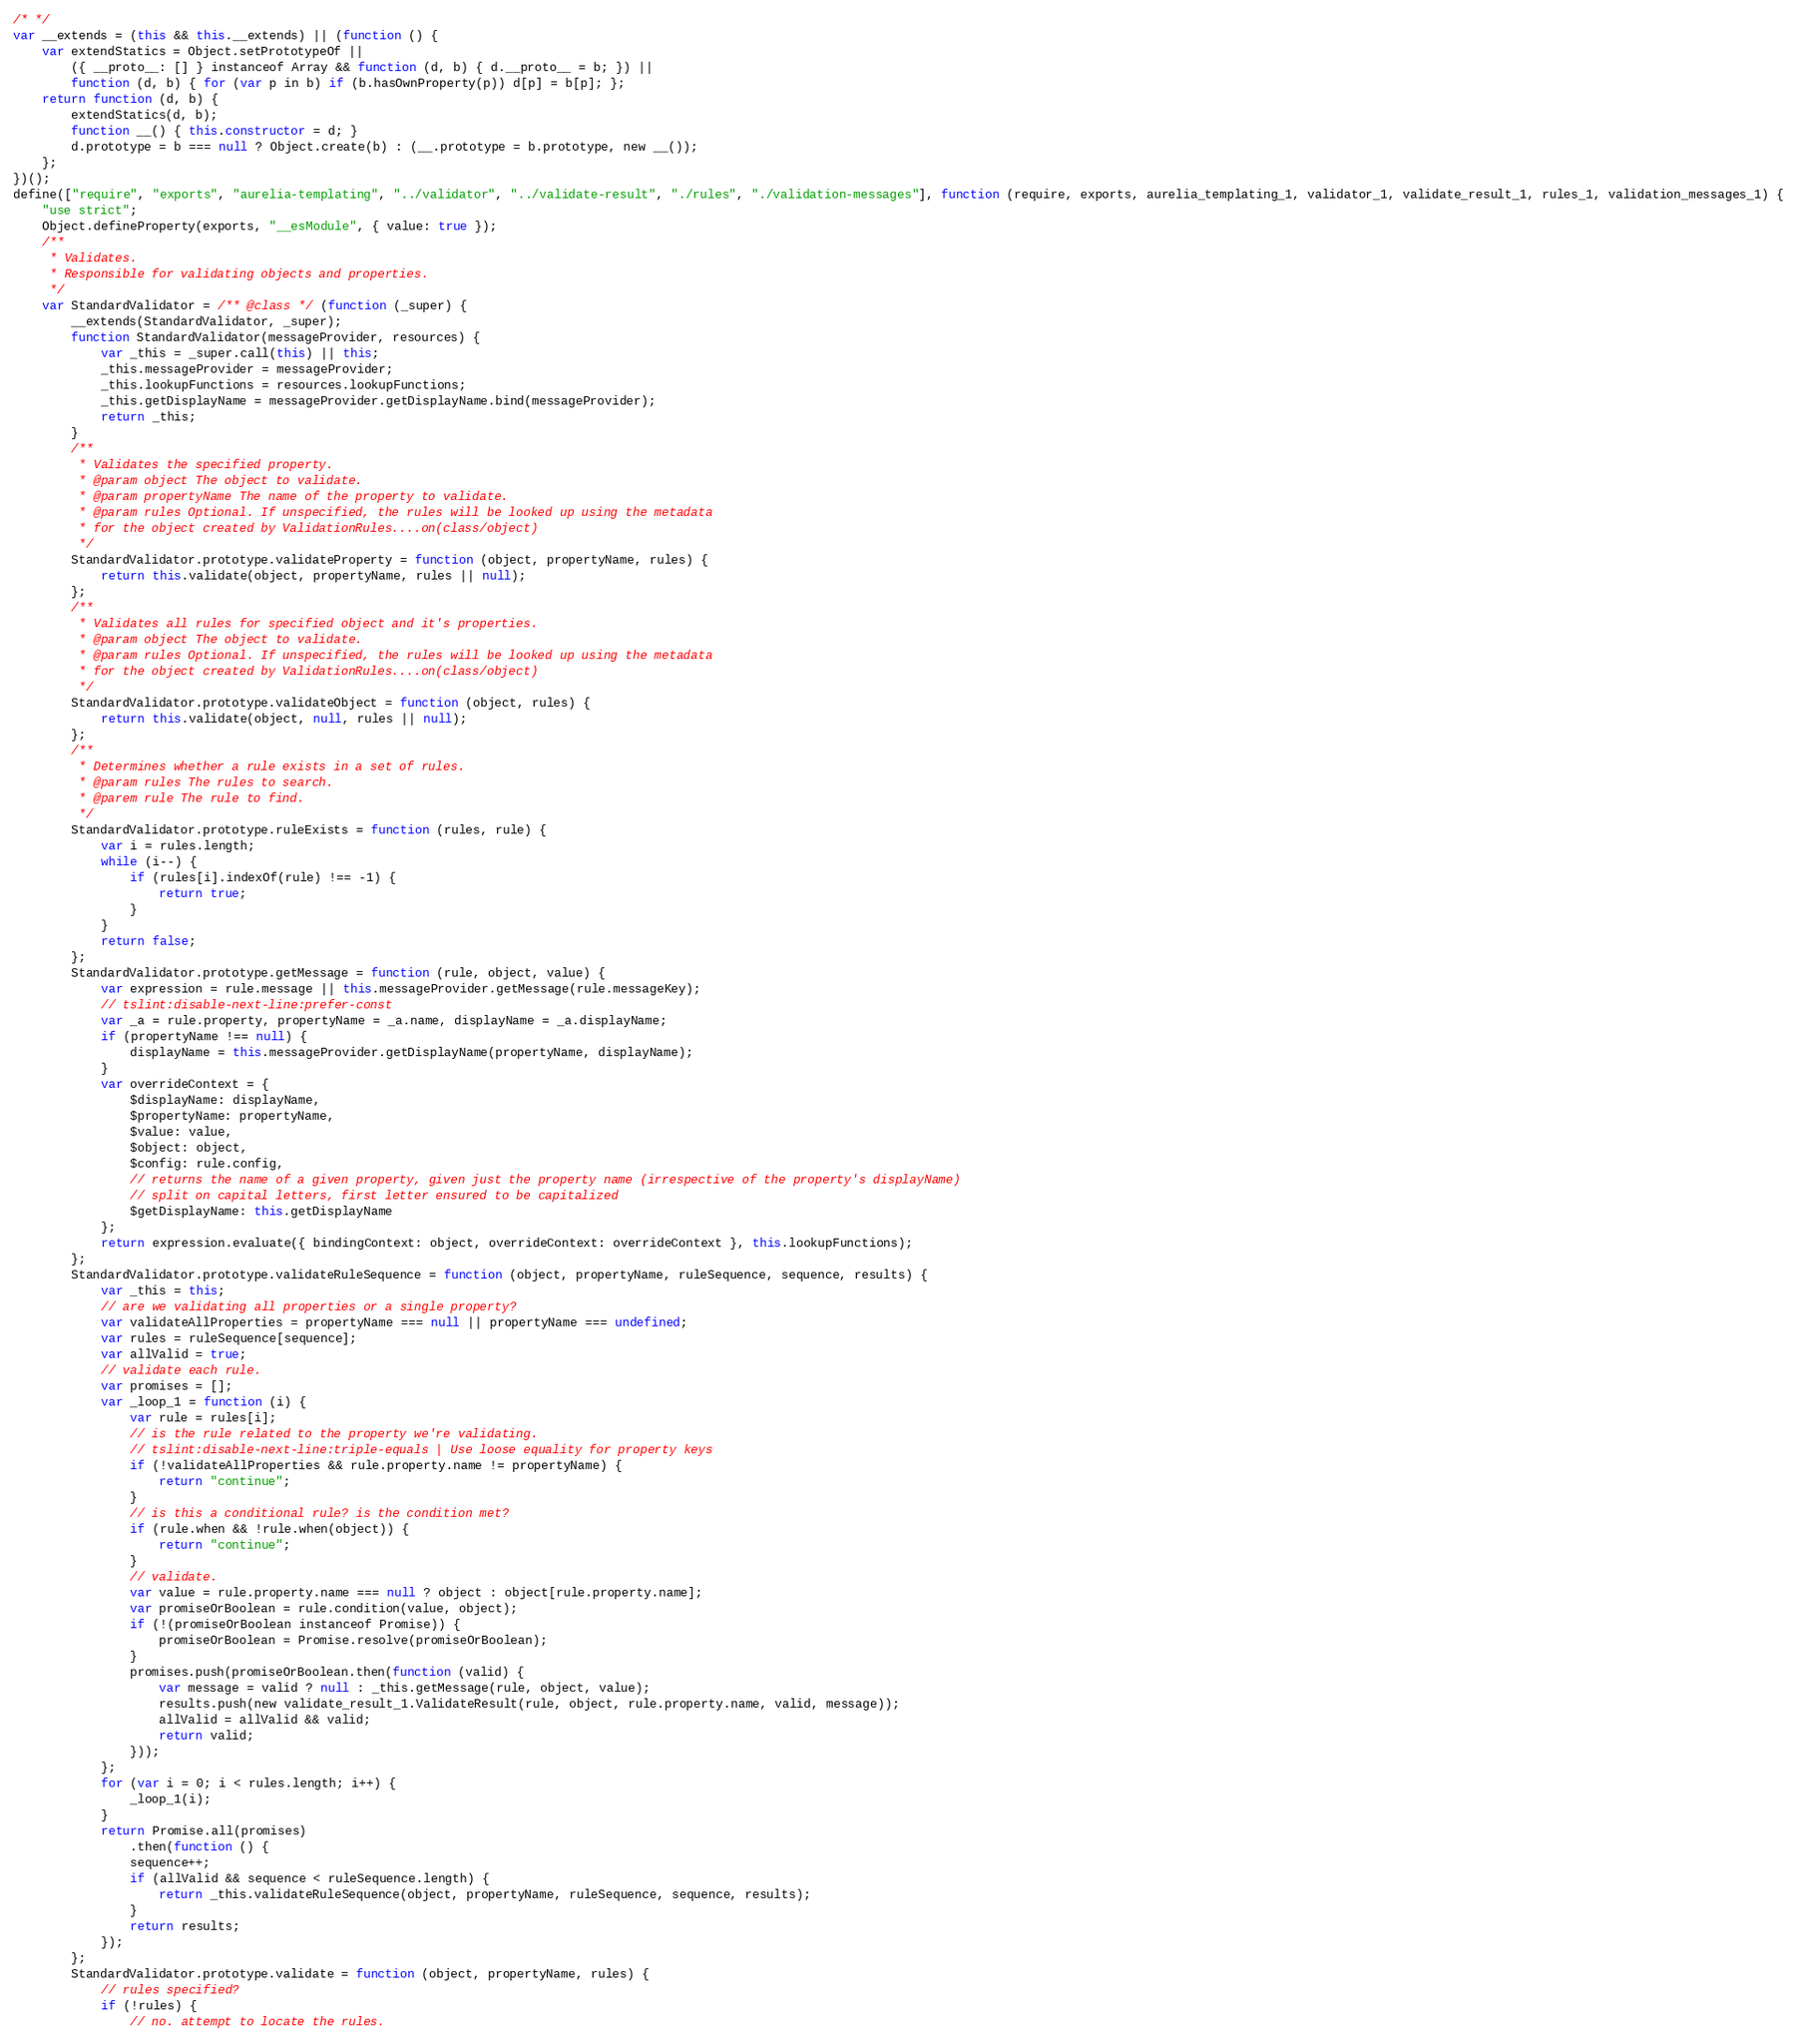Convert code to text. <code><loc_0><loc_0><loc_500><loc_500><_JavaScript_>/* */ 
var __extends = (this && this.__extends) || (function () {
    var extendStatics = Object.setPrototypeOf ||
        ({ __proto__: [] } instanceof Array && function (d, b) { d.__proto__ = b; }) ||
        function (d, b) { for (var p in b) if (b.hasOwnProperty(p)) d[p] = b[p]; };
    return function (d, b) {
        extendStatics(d, b);
        function __() { this.constructor = d; }
        d.prototype = b === null ? Object.create(b) : (__.prototype = b.prototype, new __());
    };
})();
define(["require", "exports", "aurelia-templating", "../validator", "../validate-result", "./rules", "./validation-messages"], function (require, exports, aurelia_templating_1, validator_1, validate_result_1, rules_1, validation_messages_1) {
    "use strict";
    Object.defineProperty(exports, "__esModule", { value: true });
    /**
     * Validates.
     * Responsible for validating objects and properties.
     */
    var StandardValidator = /** @class */ (function (_super) {
        __extends(StandardValidator, _super);
        function StandardValidator(messageProvider, resources) {
            var _this = _super.call(this) || this;
            _this.messageProvider = messageProvider;
            _this.lookupFunctions = resources.lookupFunctions;
            _this.getDisplayName = messageProvider.getDisplayName.bind(messageProvider);
            return _this;
        }
        /**
         * Validates the specified property.
         * @param object The object to validate.
         * @param propertyName The name of the property to validate.
         * @param rules Optional. If unspecified, the rules will be looked up using the metadata
         * for the object created by ValidationRules....on(class/object)
         */
        StandardValidator.prototype.validateProperty = function (object, propertyName, rules) {
            return this.validate(object, propertyName, rules || null);
        };
        /**
         * Validates all rules for specified object and it's properties.
         * @param object The object to validate.
         * @param rules Optional. If unspecified, the rules will be looked up using the metadata
         * for the object created by ValidationRules....on(class/object)
         */
        StandardValidator.prototype.validateObject = function (object, rules) {
            return this.validate(object, null, rules || null);
        };
        /**
         * Determines whether a rule exists in a set of rules.
         * @param rules The rules to search.
         * @parem rule The rule to find.
         */
        StandardValidator.prototype.ruleExists = function (rules, rule) {
            var i = rules.length;
            while (i--) {
                if (rules[i].indexOf(rule) !== -1) {
                    return true;
                }
            }
            return false;
        };
        StandardValidator.prototype.getMessage = function (rule, object, value) {
            var expression = rule.message || this.messageProvider.getMessage(rule.messageKey);
            // tslint:disable-next-line:prefer-const
            var _a = rule.property, propertyName = _a.name, displayName = _a.displayName;
            if (propertyName !== null) {
                displayName = this.messageProvider.getDisplayName(propertyName, displayName);
            }
            var overrideContext = {
                $displayName: displayName,
                $propertyName: propertyName,
                $value: value,
                $object: object,
                $config: rule.config,
                // returns the name of a given property, given just the property name (irrespective of the property's displayName)
                // split on capital letters, first letter ensured to be capitalized
                $getDisplayName: this.getDisplayName
            };
            return expression.evaluate({ bindingContext: object, overrideContext: overrideContext }, this.lookupFunctions);
        };
        StandardValidator.prototype.validateRuleSequence = function (object, propertyName, ruleSequence, sequence, results) {
            var _this = this;
            // are we validating all properties or a single property?
            var validateAllProperties = propertyName === null || propertyName === undefined;
            var rules = ruleSequence[sequence];
            var allValid = true;
            // validate each rule.
            var promises = [];
            var _loop_1 = function (i) {
                var rule = rules[i];
                // is the rule related to the property we're validating.
                // tslint:disable-next-line:triple-equals | Use loose equality for property keys
                if (!validateAllProperties && rule.property.name != propertyName) {
                    return "continue";
                }
                // is this a conditional rule? is the condition met?
                if (rule.when && !rule.when(object)) {
                    return "continue";
                }
                // validate.
                var value = rule.property.name === null ? object : object[rule.property.name];
                var promiseOrBoolean = rule.condition(value, object);
                if (!(promiseOrBoolean instanceof Promise)) {
                    promiseOrBoolean = Promise.resolve(promiseOrBoolean);
                }
                promises.push(promiseOrBoolean.then(function (valid) {
                    var message = valid ? null : _this.getMessage(rule, object, value);
                    results.push(new validate_result_1.ValidateResult(rule, object, rule.property.name, valid, message));
                    allValid = allValid && valid;
                    return valid;
                }));
            };
            for (var i = 0; i < rules.length; i++) {
                _loop_1(i);
            }
            return Promise.all(promises)
                .then(function () {
                sequence++;
                if (allValid && sequence < ruleSequence.length) {
                    return _this.validateRuleSequence(object, propertyName, ruleSequence, sequence, results);
                }
                return results;
            });
        };
        StandardValidator.prototype.validate = function (object, propertyName, rules) {
            // rules specified?
            if (!rules) {
                // no. attempt to locate the rules.</code> 